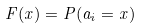Convert formula to latex. <formula><loc_0><loc_0><loc_500><loc_500>F ( x ) = P ( a _ { i } = x )</formula> 